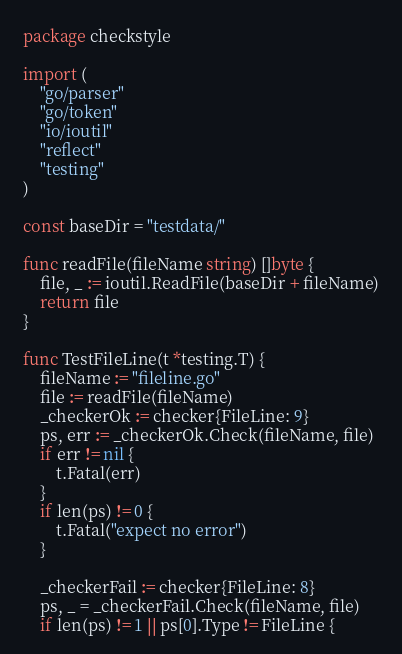Convert code to text. <code><loc_0><loc_0><loc_500><loc_500><_Go_>package checkstyle

import (
	"go/parser"
	"go/token"
	"io/ioutil"
	"reflect"
	"testing"
)

const baseDir = "testdata/"

func readFile(fileName string) []byte {
	file, _ := ioutil.ReadFile(baseDir + fileName)
	return file
}

func TestFileLine(t *testing.T) {
	fileName := "fileline.go"
	file := readFile(fileName)
	_checkerOk := checker{FileLine: 9}
	ps, err := _checkerOk.Check(fileName, file)
	if err != nil {
		t.Fatal(err)
	}
	if len(ps) != 0 {
		t.Fatal("expect no error")
	}

	_checkerFail := checker{FileLine: 8}
	ps, _ = _checkerFail.Check(fileName, file)
	if len(ps) != 1 || ps[0].Type != FileLine {</code> 